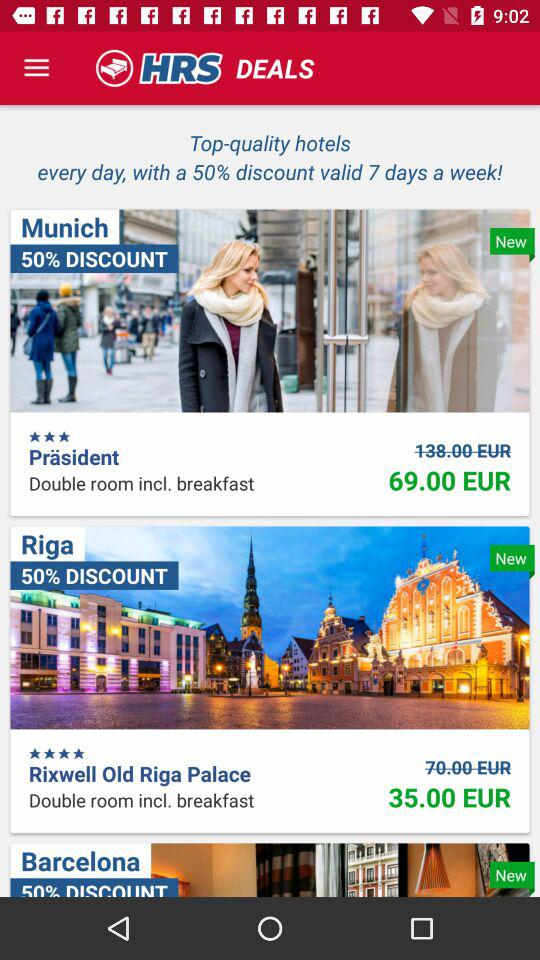What is the rating of "Präsident"? The rating of "Präsident" is 3 stars. 